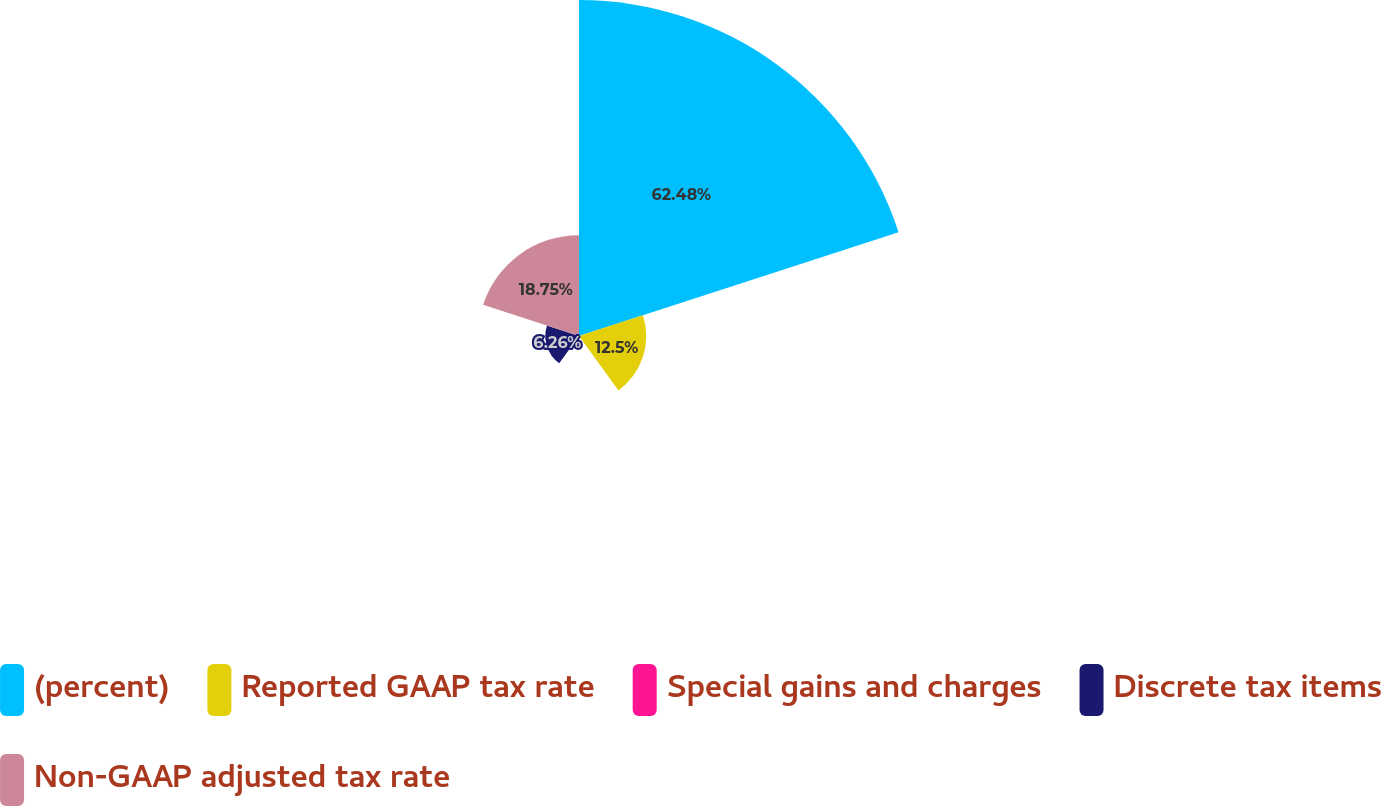Convert chart. <chart><loc_0><loc_0><loc_500><loc_500><pie_chart><fcel>(percent)<fcel>Reported GAAP tax rate<fcel>Special gains and charges<fcel>Discrete tax items<fcel>Non-GAAP adjusted tax rate<nl><fcel>62.47%<fcel>12.5%<fcel>0.01%<fcel>6.26%<fcel>18.75%<nl></chart> 